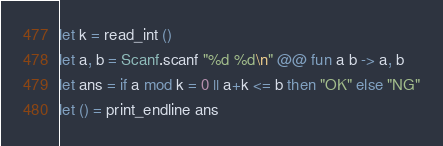Convert code to text. <code><loc_0><loc_0><loc_500><loc_500><_OCaml_>let k = read_int ()
let a, b = Scanf.scanf "%d %d\n" @@ fun a b -> a, b
let ans = if a mod k = 0 || a+k <= b then "OK" else "NG"
let () = print_endline ans</code> 